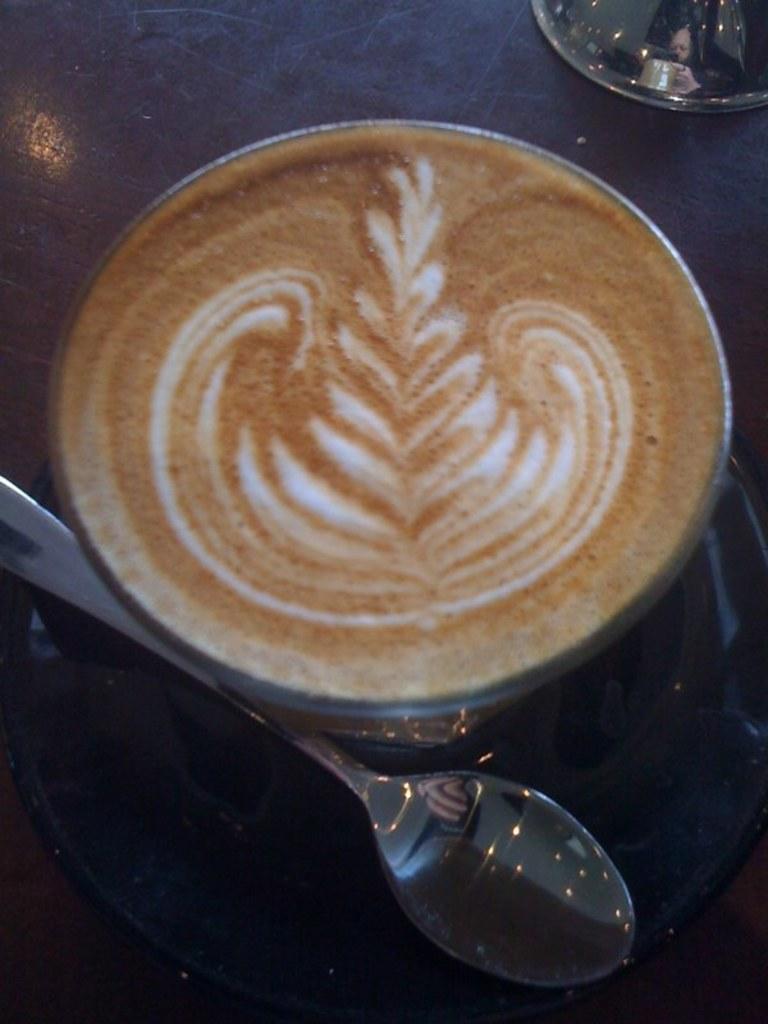Can you describe this image briefly? In this image we can see a coffee cup and a spoon on the table. 